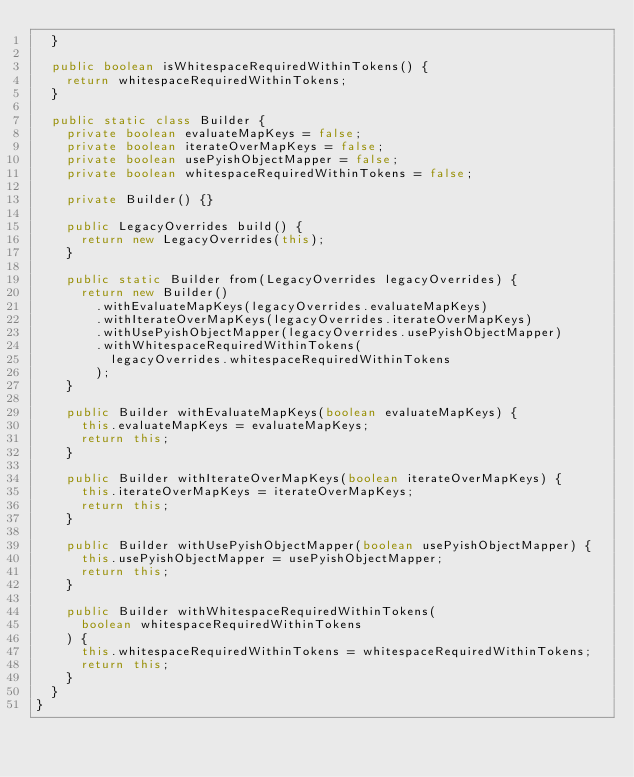<code> <loc_0><loc_0><loc_500><loc_500><_Java_>  }

  public boolean isWhitespaceRequiredWithinTokens() {
    return whitespaceRequiredWithinTokens;
  }

  public static class Builder {
    private boolean evaluateMapKeys = false;
    private boolean iterateOverMapKeys = false;
    private boolean usePyishObjectMapper = false;
    private boolean whitespaceRequiredWithinTokens = false;

    private Builder() {}

    public LegacyOverrides build() {
      return new LegacyOverrides(this);
    }

    public static Builder from(LegacyOverrides legacyOverrides) {
      return new Builder()
        .withEvaluateMapKeys(legacyOverrides.evaluateMapKeys)
        .withIterateOverMapKeys(legacyOverrides.iterateOverMapKeys)
        .withUsePyishObjectMapper(legacyOverrides.usePyishObjectMapper)
        .withWhitespaceRequiredWithinTokens(
          legacyOverrides.whitespaceRequiredWithinTokens
        );
    }

    public Builder withEvaluateMapKeys(boolean evaluateMapKeys) {
      this.evaluateMapKeys = evaluateMapKeys;
      return this;
    }

    public Builder withIterateOverMapKeys(boolean iterateOverMapKeys) {
      this.iterateOverMapKeys = iterateOverMapKeys;
      return this;
    }

    public Builder withUsePyishObjectMapper(boolean usePyishObjectMapper) {
      this.usePyishObjectMapper = usePyishObjectMapper;
      return this;
    }

    public Builder withWhitespaceRequiredWithinTokens(
      boolean whitespaceRequiredWithinTokens
    ) {
      this.whitespaceRequiredWithinTokens = whitespaceRequiredWithinTokens;
      return this;
    }
  }
}
</code> 